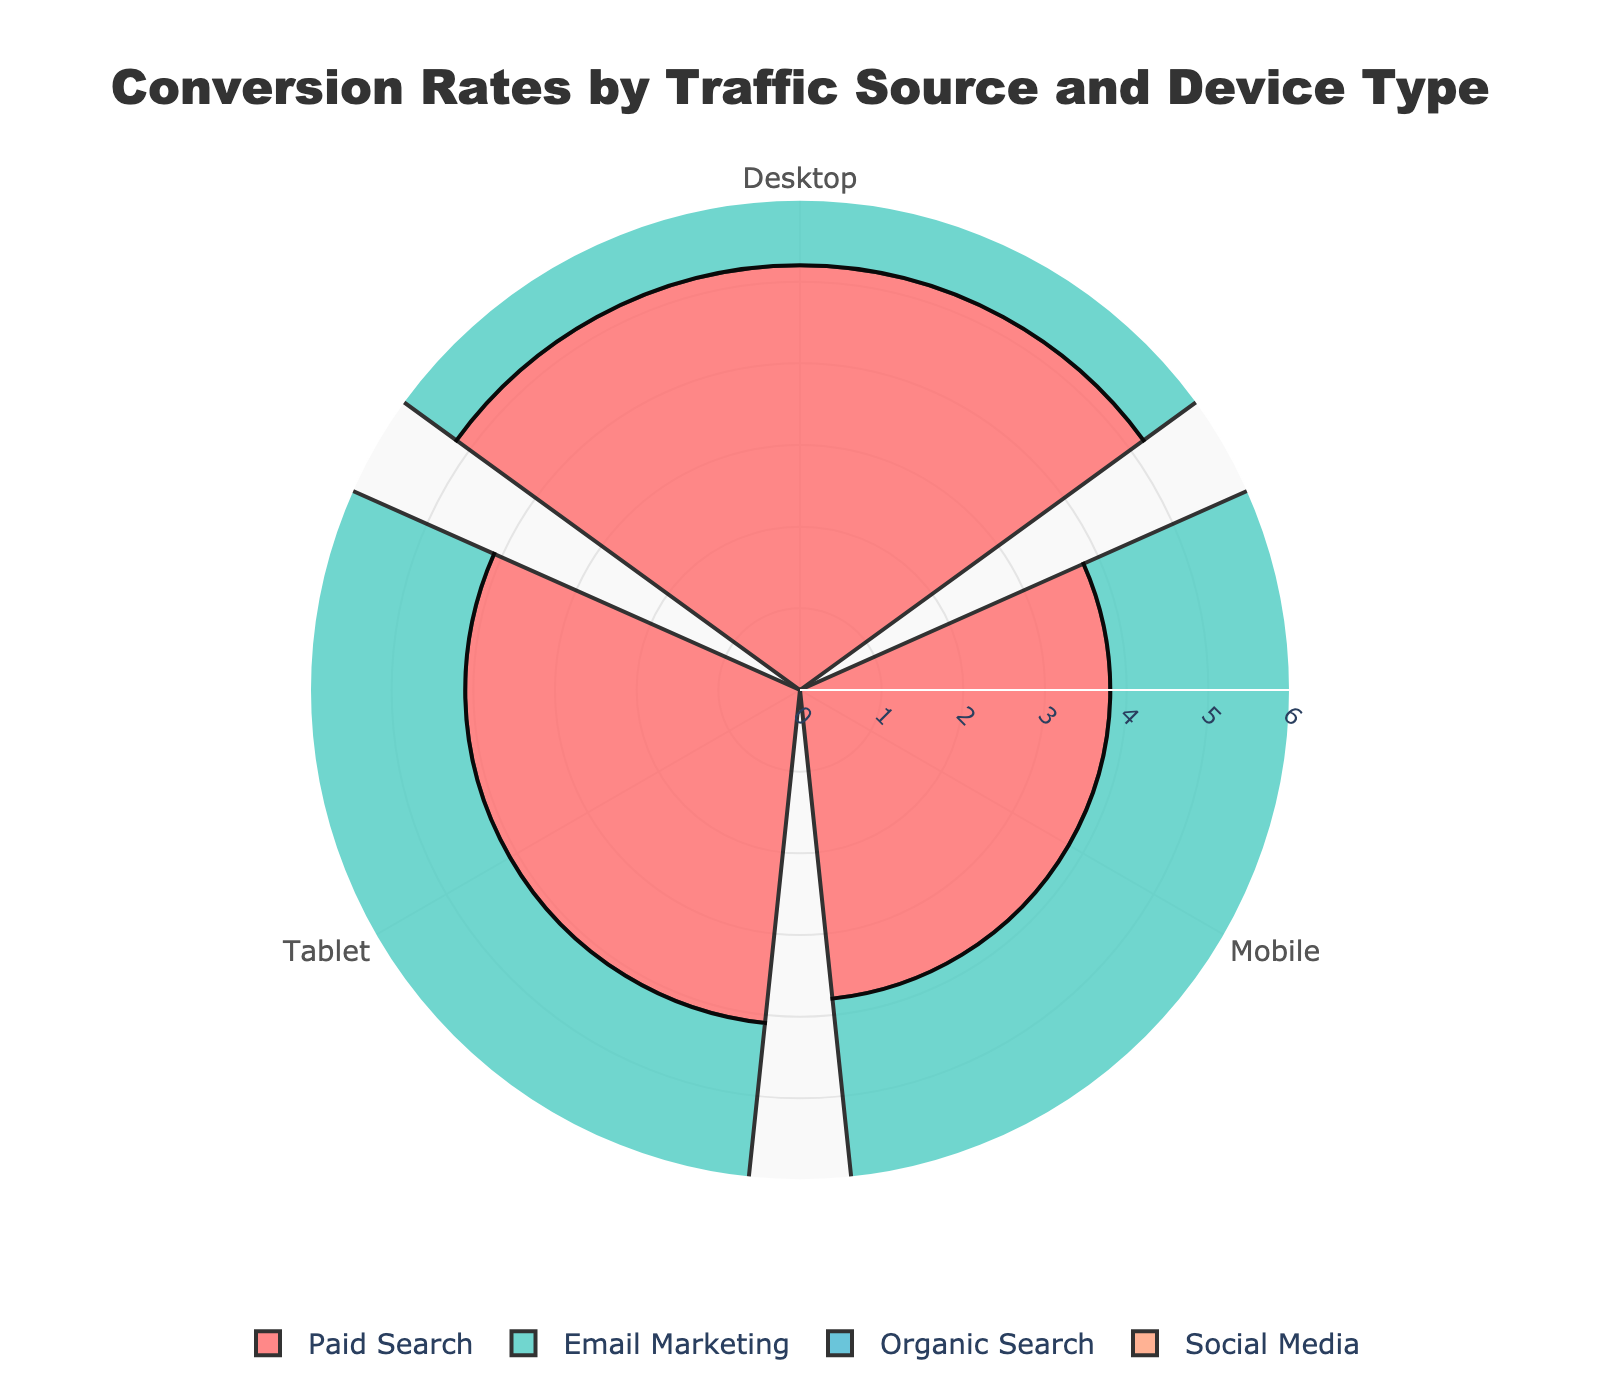What is the title of the rose chart? The title is usually found at the top of the chart and provides a brief description of its content. Here, you can see at the top center of the chart, the title is displayed.
Answer: Conversion Rates by Traffic Source and Device Type How many traffic sources are represented in the rose chart? You can determine the number of traffic sources by counting the distinct bars or segments that are individually labeled and colored. Here, four distinct colors represent four traffic sources.
Answer: Four Which traffic source has the highest average conversion rate? Look at the height (or radius) of the bars corresponding to each traffic source. The source with the largest average height is the one with the highest average conversion rate. In this case, the "Paid Search" bars appear the tallest on average.
Answer: Paid Search What device type under Email Marketing has the highest conversion rate? Focus on the bars corresponding to "Email Marketing" and compare their heights for different device types. The bar with the greatest height indicates the highest conversion rate. Here, the "Desktop" device type has the highest bar under "Email Marketing".
Answer: Desktop Is the conversion rate for Mobile higher in Organic Search or Paid Search? Compare the heights of the bars labeled "Mobile" for both "Organic Search" and "Paid Search" traffic sources. The taller bar signifies the higher conversion rate. Here, "Paid Search" Mobile has a higher bar than "Organic Search" Mobile.
Answer: Paid Search What is the average conversion rate across all Device Types for Social Media? To find the average, add up the heights (conversion rates) for Desktop, Mobile, and Tablet under "Social Media" and then divide by 3. The values are 2.2%, 3.0%, and 2.4% respectively. The average is calculated as (2.2 + 3.0 + 2.4) / 3.
Answer: 2.53 Which traffic source has the lowest conversion rate for the Desktop device type? Locate the bars labeled "Desktop" for all traffic sources and identify the shortest bar. The shortest bar represents the lowest conversion rate. Here, the "Social Media" Desktop bar is the shortest.
Answer: Social Media Are the conversion rates for Tablet devices generally higher or lower than those for Mobile devices across traffic sources? Compare the heights of the bars for "Tablet" and "Mobile" within each traffic source. Assess if "Tablet" bars are generally higher or lower compared to "Mobile" bars. Overall, "Tablet" bars seem lower than "Mobile" bars.
Answer: Lower What is the difference in conversion rate between Desktop and Mobile for Paid Search? Identify the heights of the bars for "Desktop" and "Mobile" under the "Paid Search" traffic source. Subtract the conversion rate for Mobile (3.8%) from that for Desktop (5.2%).
Answer: 1.4 Which traffic source shows the smallest range of conversion rates across device types? Calculate the range for each traffic source by finding the difference between the highest and lowest conversion rates within each traffic source. The traffic source with the smallest difference is the answer. "Social Media" has conversion rates of 2.2%, 3.0%, and 2.4%, yielding the smallest range.
Answer: Social Media 